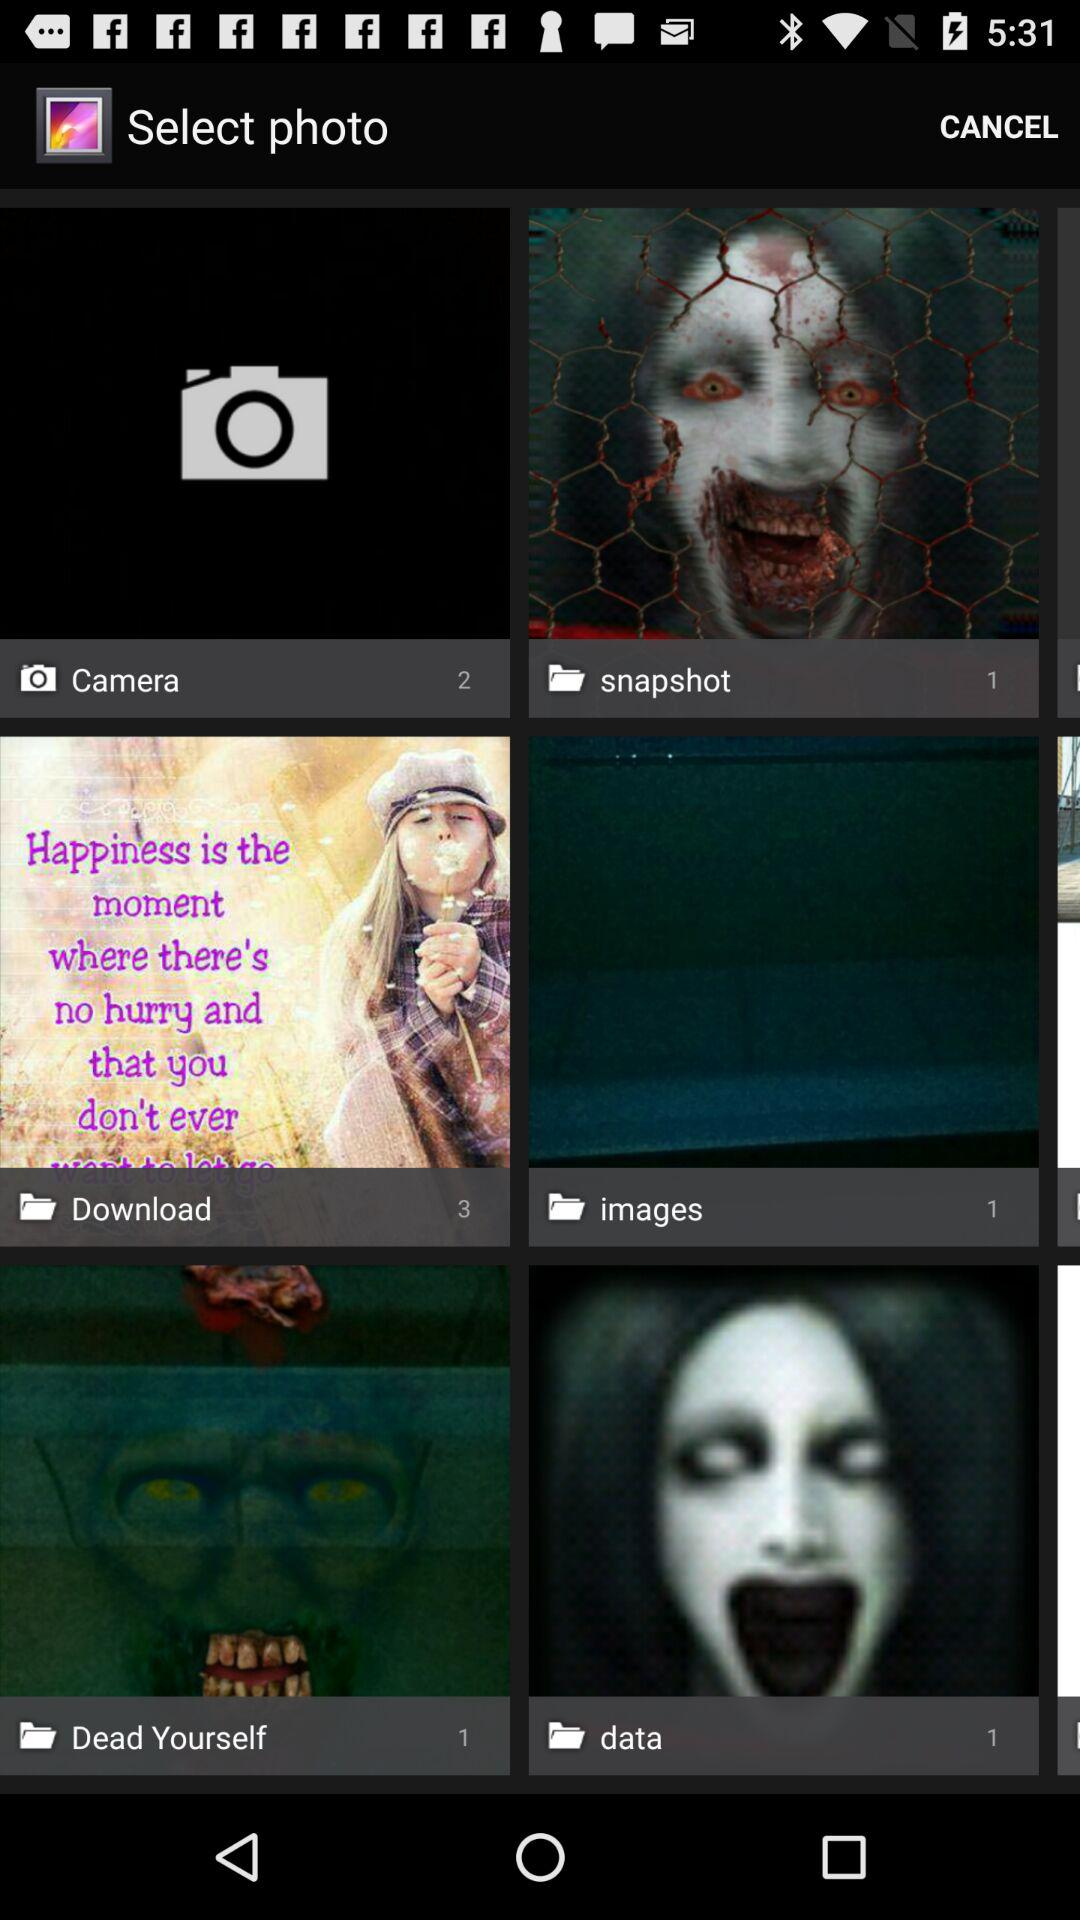How many photos are there in the "Camera" folder? There are 2 photos in the "Camera" folder. 